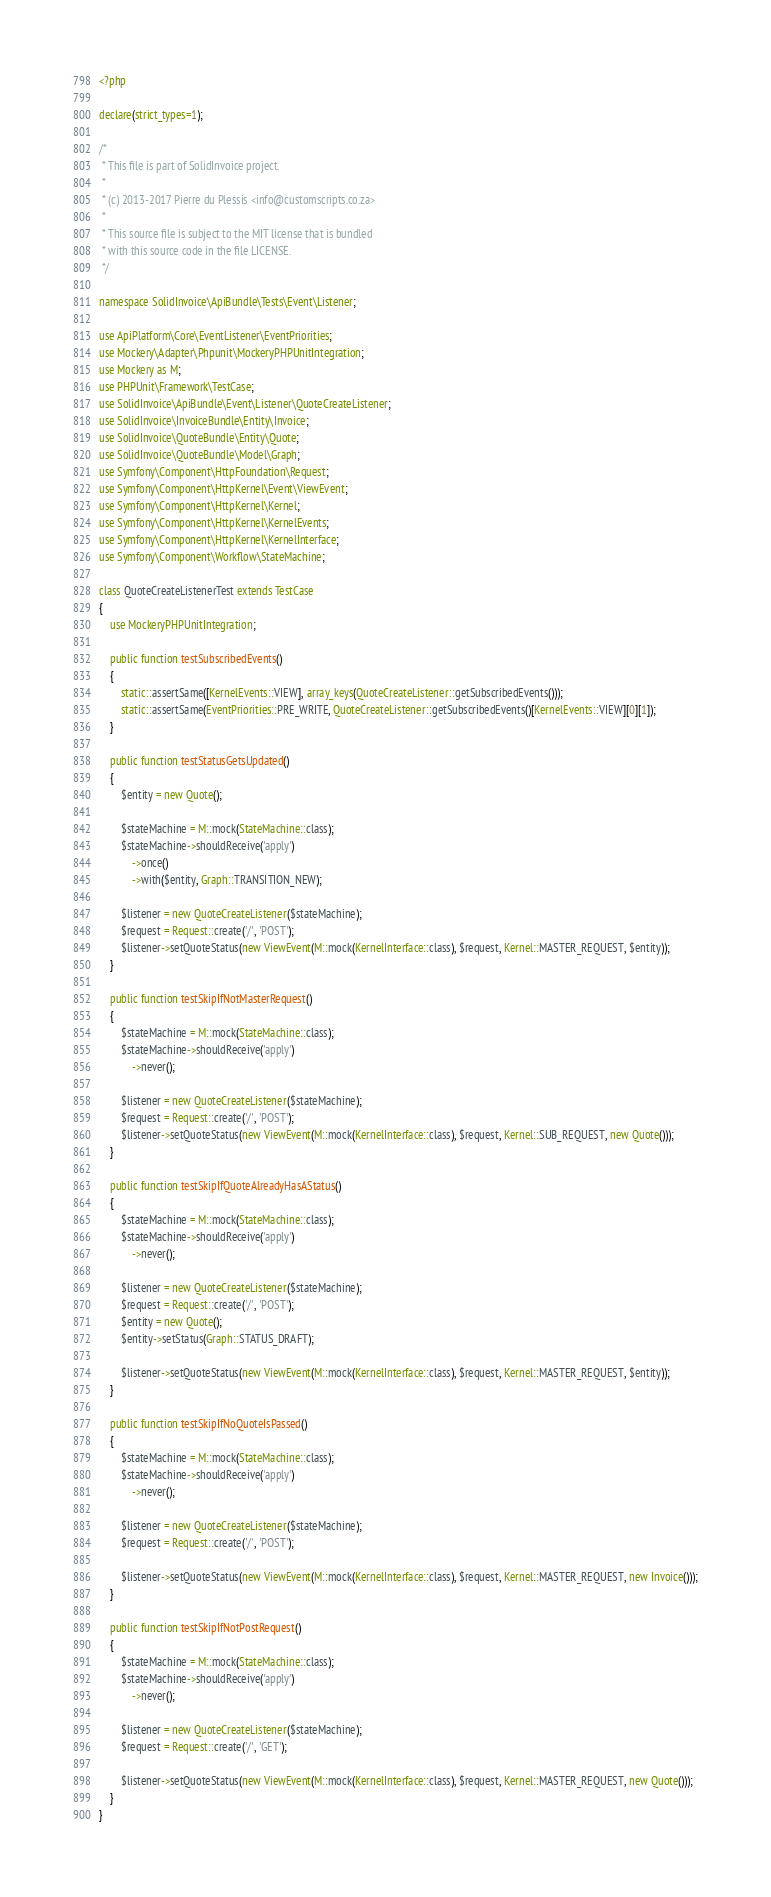<code> <loc_0><loc_0><loc_500><loc_500><_PHP_><?php

declare(strict_types=1);

/*
 * This file is part of SolidInvoice project.
 *
 * (c) 2013-2017 Pierre du Plessis <info@customscripts.co.za>
 *
 * This source file is subject to the MIT license that is bundled
 * with this source code in the file LICENSE.
 */

namespace SolidInvoice\ApiBundle\Tests\Event\Listener;

use ApiPlatform\Core\EventListener\EventPriorities;
use Mockery\Adapter\Phpunit\MockeryPHPUnitIntegration;
use Mockery as M;
use PHPUnit\Framework\TestCase;
use SolidInvoice\ApiBundle\Event\Listener\QuoteCreateListener;
use SolidInvoice\InvoiceBundle\Entity\Invoice;
use SolidInvoice\QuoteBundle\Entity\Quote;
use SolidInvoice\QuoteBundle\Model\Graph;
use Symfony\Component\HttpFoundation\Request;
use Symfony\Component\HttpKernel\Event\ViewEvent;
use Symfony\Component\HttpKernel\Kernel;
use Symfony\Component\HttpKernel\KernelEvents;
use Symfony\Component\HttpKernel\KernelInterface;
use Symfony\Component\Workflow\StateMachine;

class QuoteCreateListenerTest extends TestCase
{
    use MockeryPHPUnitIntegration;

    public function testSubscribedEvents()
    {
        static::assertSame([KernelEvents::VIEW], array_keys(QuoteCreateListener::getSubscribedEvents()));
        static::assertSame(EventPriorities::PRE_WRITE, QuoteCreateListener::getSubscribedEvents()[KernelEvents::VIEW][0][1]);
    }

    public function testStatusGetsUpdated()
    {
        $entity = new Quote();

        $stateMachine = M::mock(StateMachine::class);
        $stateMachine->shouldReceive('apply')
            ->once()
            ->with($entity, Graph::TRANSITION_NEW);

        $listener = new QuoteCreateListener($stateMachine);
        $request = Request::create('/', 'POST');
        $listener->setQuoteStatus(new ViewEvent(M::mock(KernelInterface::class), $request, Kernel::MASTER_REQUEST, $entity));
    }

    public function testSkipIfNotMasterRequest()
    {
        $stateMachine = M::mock(StateMachine::class);
        $stateMachine->shouldReceive('apply')
            ->never();

        $listener = new QuoteCreateListener($stateMachine);
        $request = Request::create('/', 'POST');
        $listener->setQuoteStatus(new ViewEvent(M::mock(KernelInterface::class), $request, Kernel::SUB_REQUEST, new Quote()));
    }

    public function testSkipIfQuoteAlreadyHasAStatus()
    {
        $stateMachine = M::mock(StateMachine::class);
        $stateMachine->shouldReceive('apply')
            ->never();

        $listener = new QuoteCreateListener($stateMachine);
        $request = Request::create('/', 'POST');
        $entity = new Quote();
        $entity->setStatus(Graph::STATUS_DRAFT);

        $listener->setQuoteStatus(new ViewEvent(M::mock(KernelInterface::class), $request, Kernel::MASTER_REQUEST, $entity));
    }

    public function testSkipIfNoQuoteIsPassed()
    {
        $stateMachine = M::mock(StateMachine::class);
        $stateMachine->shouldReceive('apply')
            ->never();

        $listener = new QuoteCreateListener($stateMachine);
        $request = Request::create('/', 'POST');

        $listener->setQuoteStatus(new ViewEvent(M::mock(KernelInterface::class), $request, Kernel::MASTER_REQUEST, new Invoice()));
    }

    public function testSkipIfNotPostRequest()
    {
        $stateMachine = M::mock(StateMachine::class);
        $stateMachine->shouldReceive('apply')
            ->never();

        $listener = new QuoteCreateListener($stateMachine);
        $request = Request::create('/', 'GET');

        $listener->setQuoteStatus(new ViewEvent(M::mock(KernelInterface::class), $request, Kernel::MASTER_REQUEST, new Quote()));
    }
}
</code> 